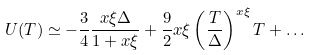Convert formula to latex. <formula><loc_0><loc_0><loc_500><loc_500>U ( T ) \simeq - \frac { 3 } { 4 } \frac { x \xi \Delta } { 1 + x \xi } + \frac { 9 } { 2 } x \xi \left ( \frac { T } { \Delta } \right ) ^ { x \xi } T + \dots</formula> 